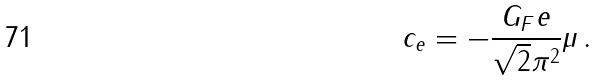<formula> <loc_0><loc_0><loc_500><loc_500>c _ { e } = - \frac { G _ { F } e } { \sqrt { 2 } \pi ^ { 2 } } \mu \, .</formula> 